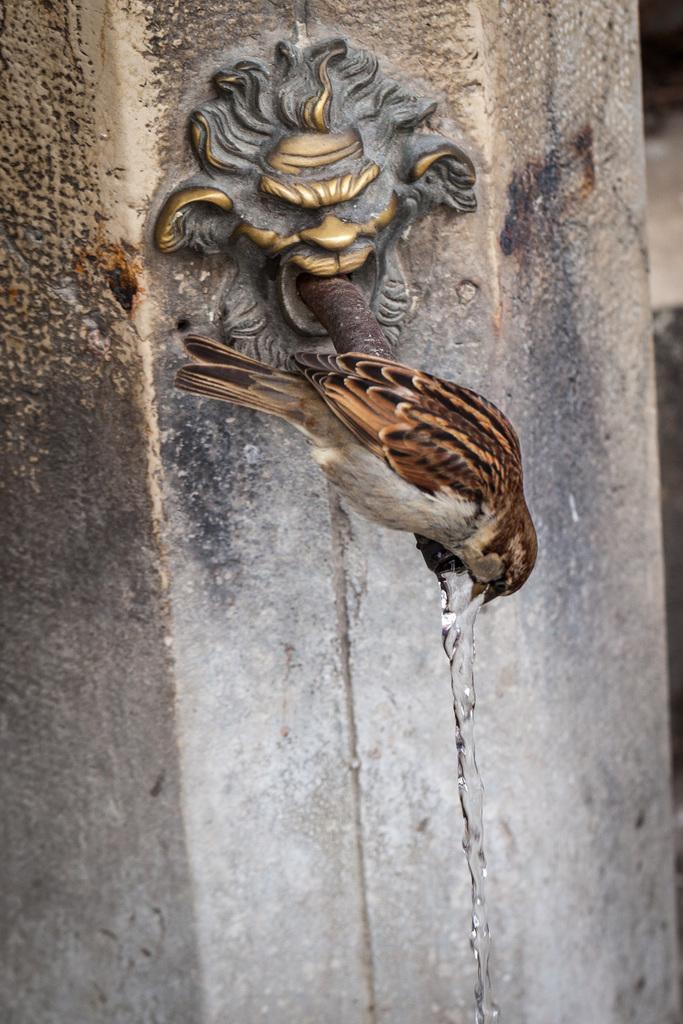Could you give a brief overview of what you see in this image? In this image, we can see a pillar, there is a bird sitting on the metal rod. 